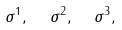<formula> <loc_0><loc_0><loc_500><loc_500>\sigma ^ { 1 } , \text { \ } \sigma ^ { 2 } , \text { \ } \sigma ^ { 3 } ,</formula> 